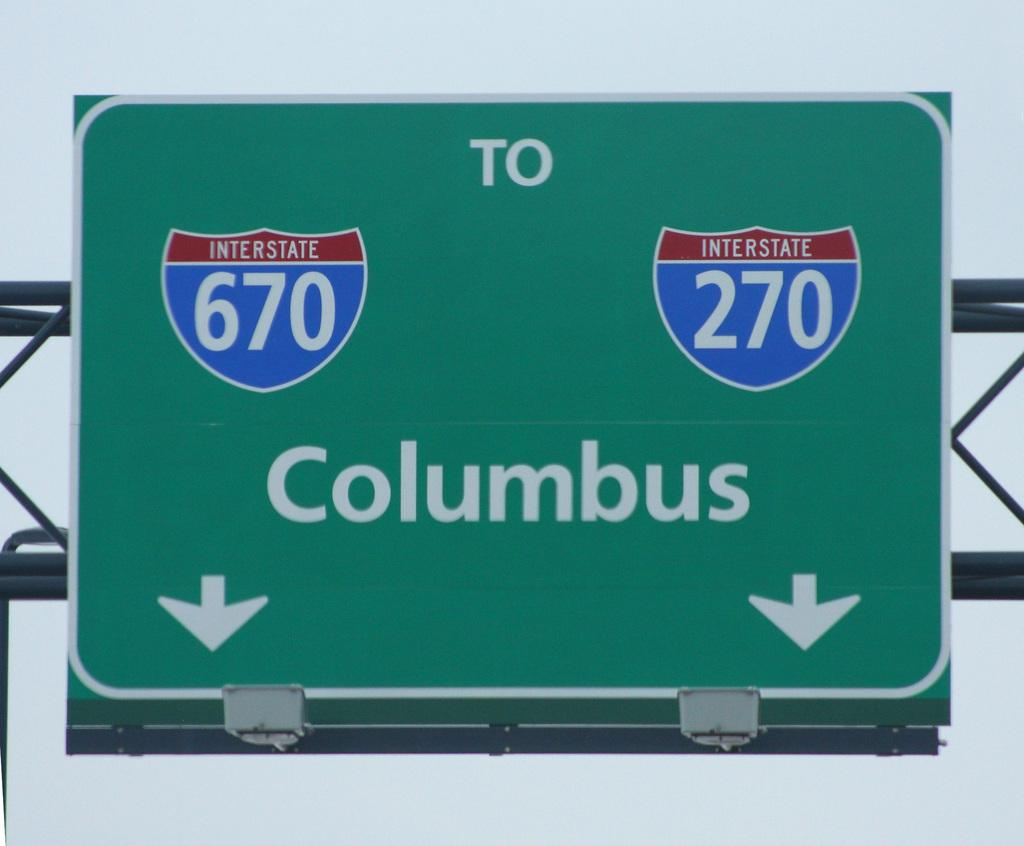Provide a one-sentence caption for the provided image. A green highway sign pointing the way to Columbus. 